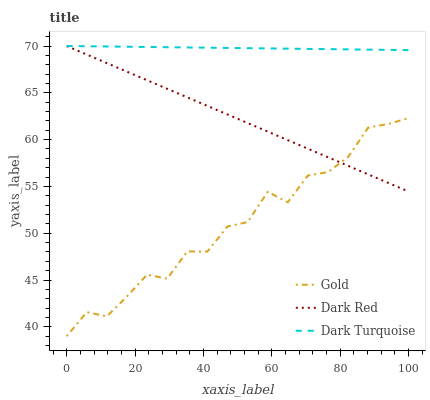Does Gold have the minimum area under the curve?
Answer yes or no. Yes. Does Dark Turquoise have the maximum area under the curve?
Answer yes or no. Yes. Does Dark Turquoise have the minimum area under the curve?
Answer yes or no. No. Does Gold have the maximum area under the curve?
Answer yes or no. No. Is Dark Red the smoothest?
Answer yes or no. Yes. Is Gold the roughest?
Answer yes or no. Yes. Is Dark Turquoise the smoothest?
Answer yes or no. No. Is Dark Turquoise the roughest?
Answer yes or no. No. Does Dark Turquoise have the lowest value?
Answer yes or no. No. Does Dark Turquoise have the highest value?
Answer yes or no. Yes. Does Gold have the highest value?
Answer yes or no. No. Is Gold less than Dark Turquoise?
Answer yes or no. Yes. Is Dark Turquoise greater than Gold?
Answer yes or no. Yes. Does Gold intersect Dark Turquoise?
Answer yes or no. No. 